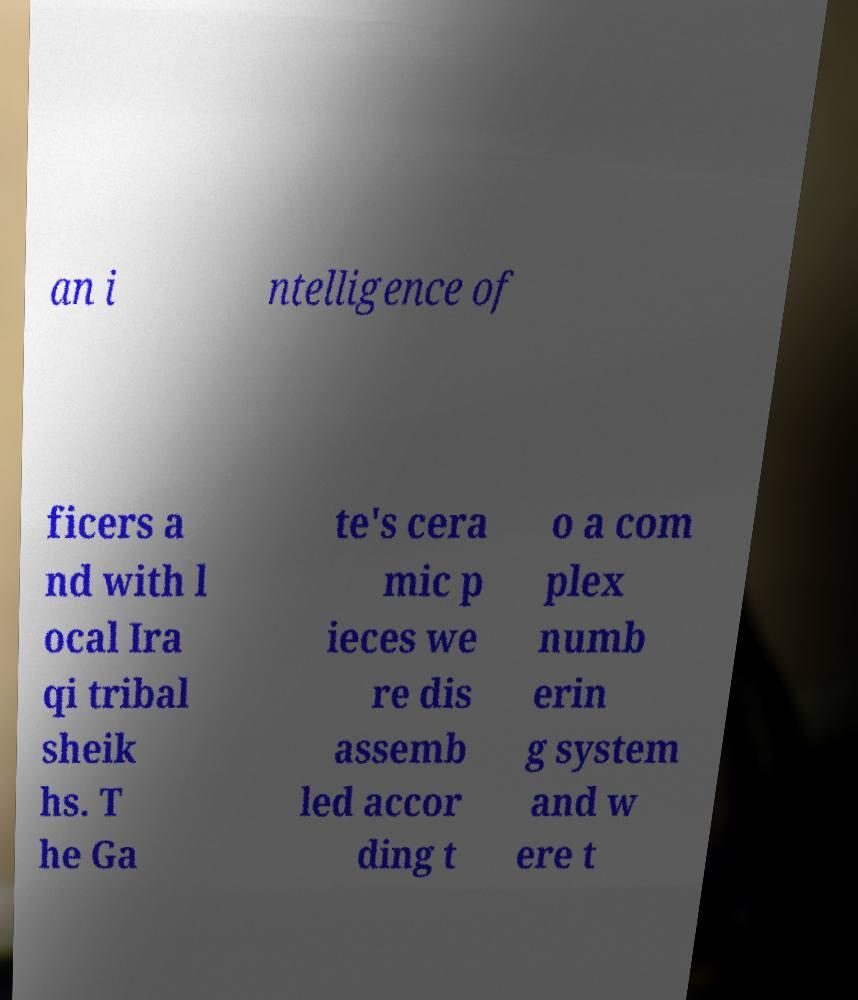Could you extract and type out the text from this image? an i ntelligence of ficers a nd with l ocal Ira qi tribal sheik hs. T he Ga te's cera mic p ieces we re dis assemb led accor ding t o a com plex numb erin g system and w ere t 